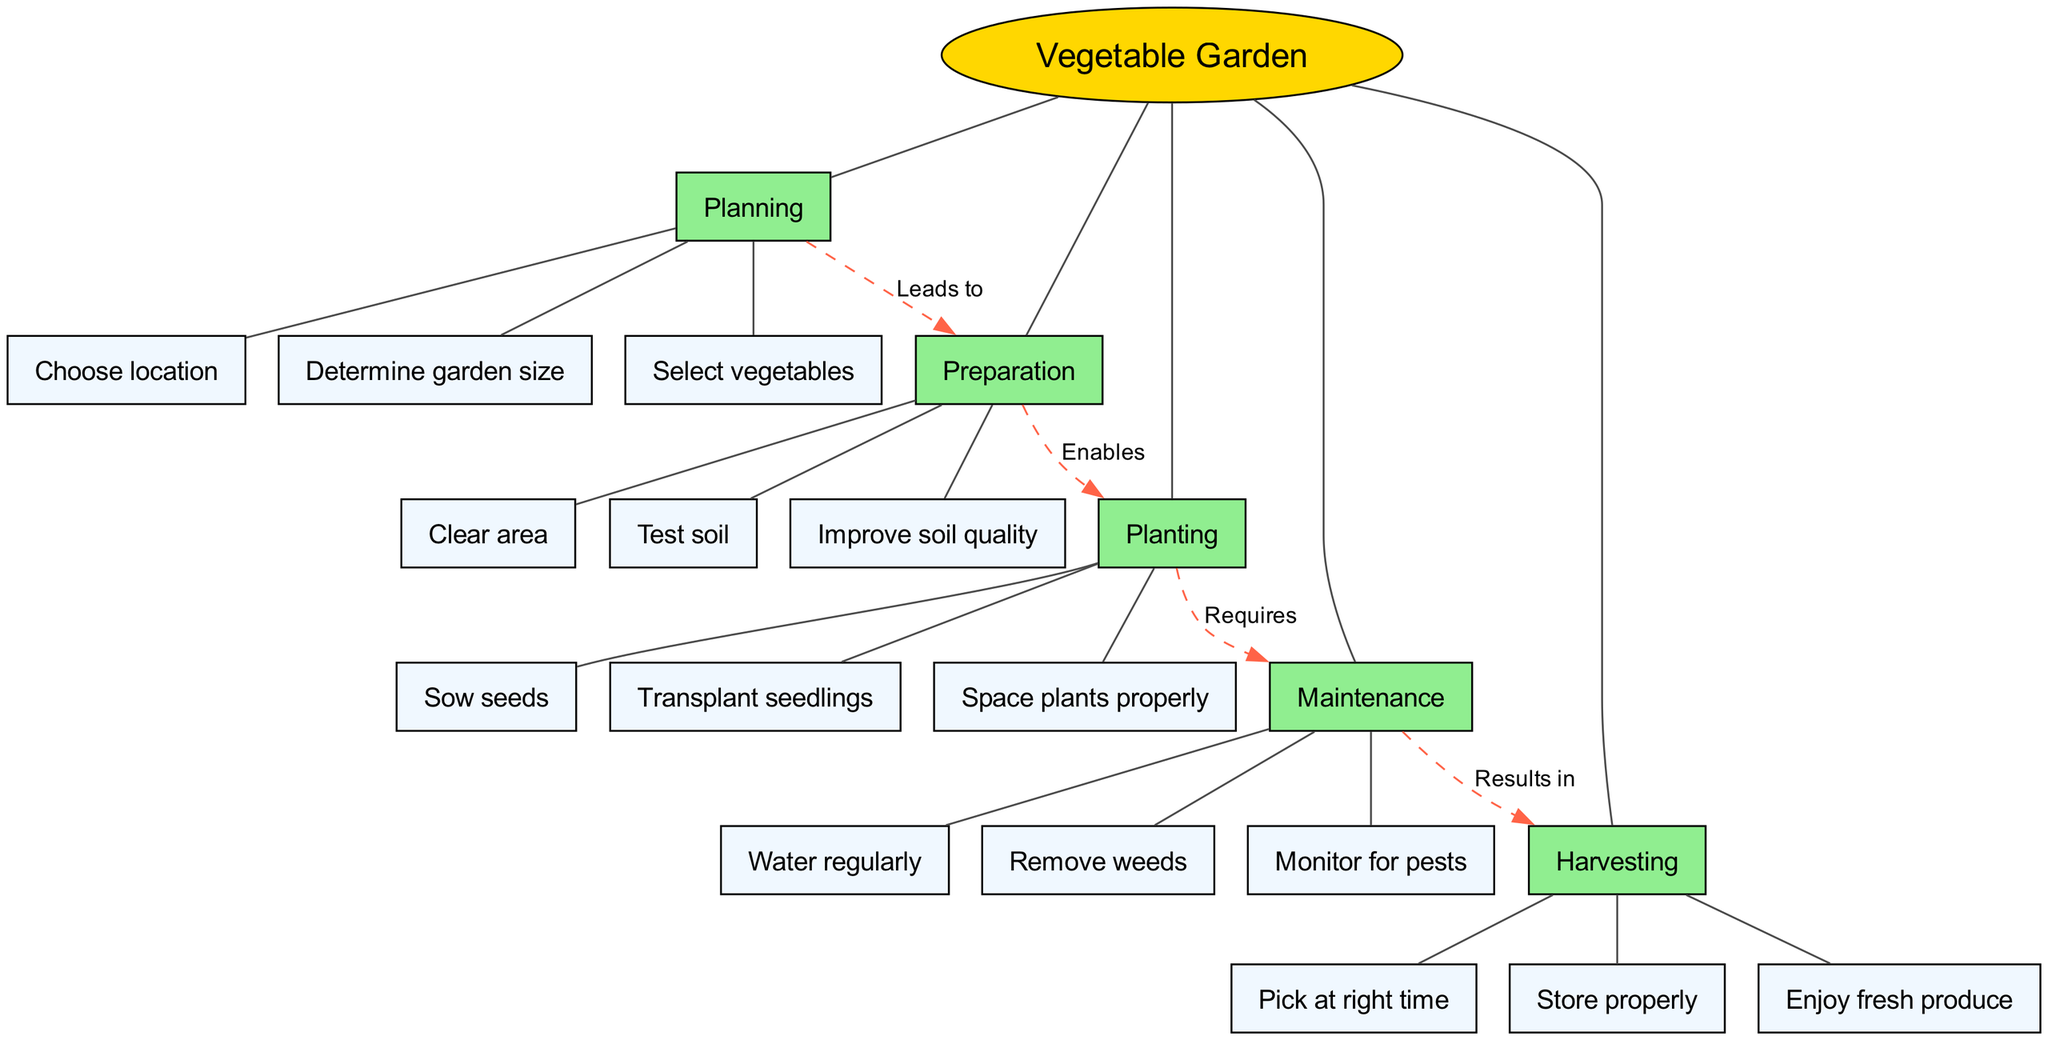What is the central concept of the diagram? The central concept is explicitly stated at the top of the diagram, which is "Vegetable Garden."
Answer: Vegetable Garden How many main branches are there? By counting the distinct main branches listed in the diagram, we can see that there are five: Planning, Preparation, Planting, Maintenance, and Harvesting.
Answer: 5 What sub-branch is under the main branch "Maintenance"? The sub-branches under "Maintenance" can be found directly beneath it, and one example is "Water regularly."
Answer: Water regularly Which main branch connects to "Preparation" and what is the nature of that connection? The diagram shows that "Planning" leads to "Preparation," indicating a directional connection where the act of planning is a prerequisite for preparation in the gardening process.
Answer: Planning, Leads to What is the last step in the process shown in the diagram? The flow of the diagram leads through various stages and culminates in "Harvesting," which is the final main branch presented.
Answer: Harvesting How does "Planting" relate to "Maintenance"? The connection between "Planting" and "Maintenance" specifies that "Planting" requires "Maintenance," indicating that planting vegetables must be followed up with regular maintenance.
Answer: Requires Which two branches are connected by a dashed line indicating a relationship? By analyzing the connections shown as dashed lines in the diagram, "Maintenance" and "Harvesting" are connected, indicating a result of the maintenance efforts.
Answer: Maintenance, Results in What is the vegetation that can be selected during the "Planning" phase? Looking at the sub-branches under "Planning," one of the sub-branches is "Select vegetables," which directly answers the question.
Answer: Select vegetables 